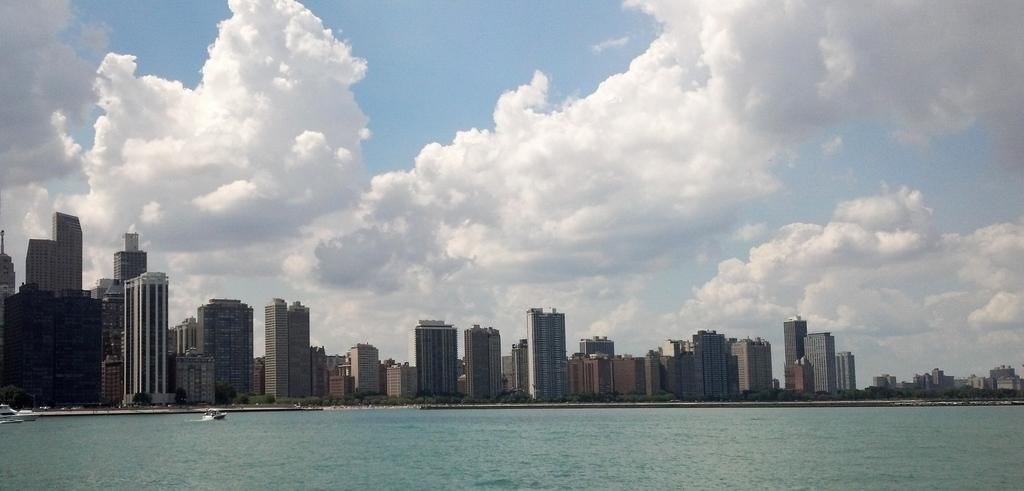What type of structures can be seen in the image? There are many buildings in the image. What natural feature is visible in the image? The sea is visible in the image. What is visible at the top of the image? The sky is visible at the top of the image. What can be observed in the sky? Clouds are present in the sky. What advice is given by the industry in the image? There is no industry present in the image, and therefore no advice can be given. What time of day is depicted in the image? The provided facts do not give any information about the time of day, so it cannot be determined from the image. 